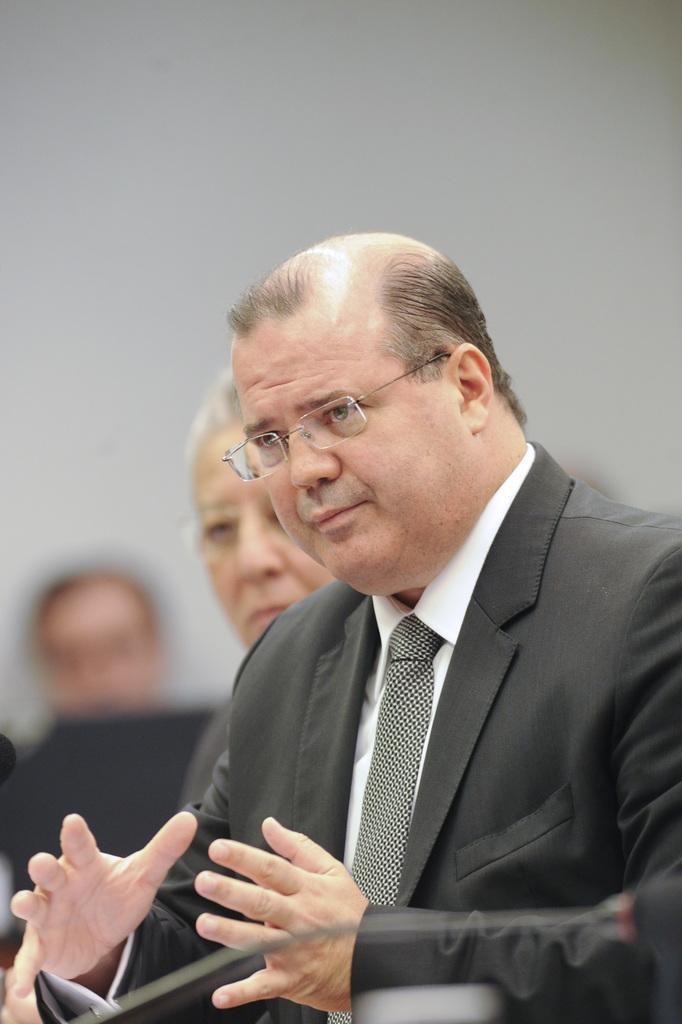How would you summarize this image in a sentence or two? In this image we can see a man wearing specs. At the bottom there is a mic. In the back there are few people. And it is blurry in the background. 